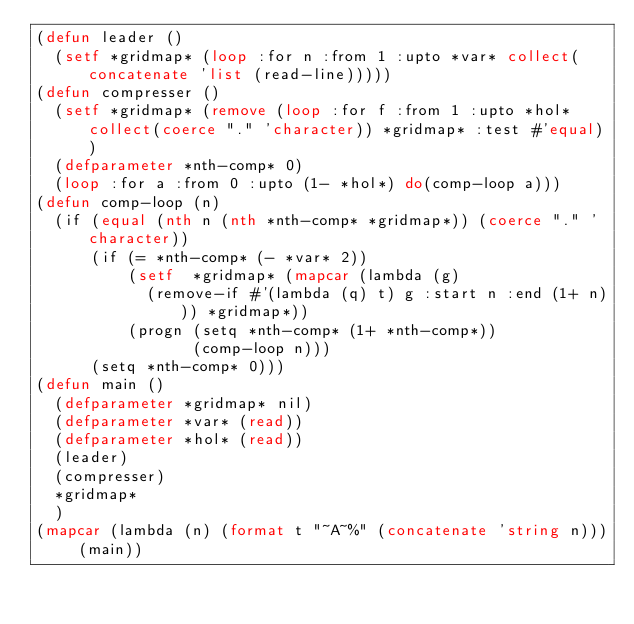<code> <loc_0><loc_0><loc_500><loc_500><_Lisp_>(defun leader ()
  (setf *gridmap* (loop :for n :from 1 :upto *var* collect(concatenate 'list (read-line)))))
(defun compresser ()
  (setf *gridmap* (remove (loop :for f :from 1 :upto *hol* collect(coerce "." 'character)) *gridmap* :test #'equal))
  (defparameter *nth-comp* 0)
  (loop :for a :from 0 :upto (1- *hol*) do(comp-loop a)))
(defun comp-loop (n)
  (if (equal (nth n (nth *nth-comp* *gridmap*)) (coerce "." 'character))
      (if (= *nth-comp* (- *var* 2))
          (setf  *gridmap* (mapcar (lambda (g)
            (remove-if #'(lambda (q) t) g :start n :end (1+ n))) *gridmap*))
          (progn (setq *nth-comp* (1+ *nth-comp*))
                 (comp-loop n)))
      (setq *nth-comp* 0)))
(defun main ()
  (defparameter *gridmap* nil)
  (defparameter *var* (read))
  (defparameter *hol* (read))
  (leader)
  (compresser)
  *gridmap*
  )
(mapcar (lambda (n) (format t "~A~%" (concatenate 'string n))) (main))
</code> 